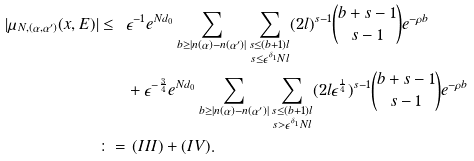<formula> <loc_0><loc_0><loc_500><loc_500>| \mu _ { N , ( \alpha , \alpha ^ { \prime } ) } ( x , E ) | \leq \ & \epsilon ^ { - 1 } e ^ { N d _ { 0 } } \sum _ { b \geq | n ( \alpha ) - n ( \alpha ^ { \prime } ) | } \sum _ { \substack { s \leq ( b + 1 ) l \\ s \leq \epsilon ^ { \delta _ { 1 } } N l } } ( 2 l ) ^ { s - 1 } \binom { b + s - 1 } { s - 1 } e ^ { - \rho b } \\ & + \epsilon ^ { - \frac { 3 } { 4 } } e ^ { N d _ { 0 } } \sum _ { b \geq | n ( \alpha ) - n ( \alpha ^ { \prime } ) | } \sum _ { \substack { s \leq ( b + 1 ) l \\ s > \epsilon ^ { \delta _ { 1 } } N l } } ( 2 l \epsilon ^ { \frac { 1 } { 4 } } ) ^ { s - 1 } \binom { b + s - 1 } { s - 1 } e ^ { - \rho b } \\ \colon = & \ ( I I I ) + ( I V ) .</formula> 